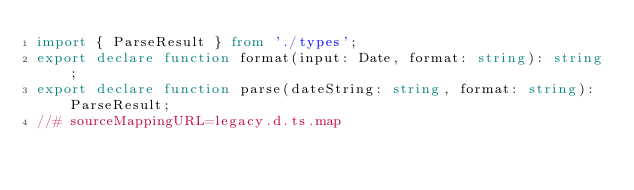Convert code to text. <code><loc_0><loc_0><loc_500><loc_500><_TypeScript_>import { ParseResult } from './types';
export declare function format(input: Date, format: string): string;
export declare function parse(dateString: string, format: string): ParseResult;
//# sourceMappingURL=legacy.d.ts.map</code> 